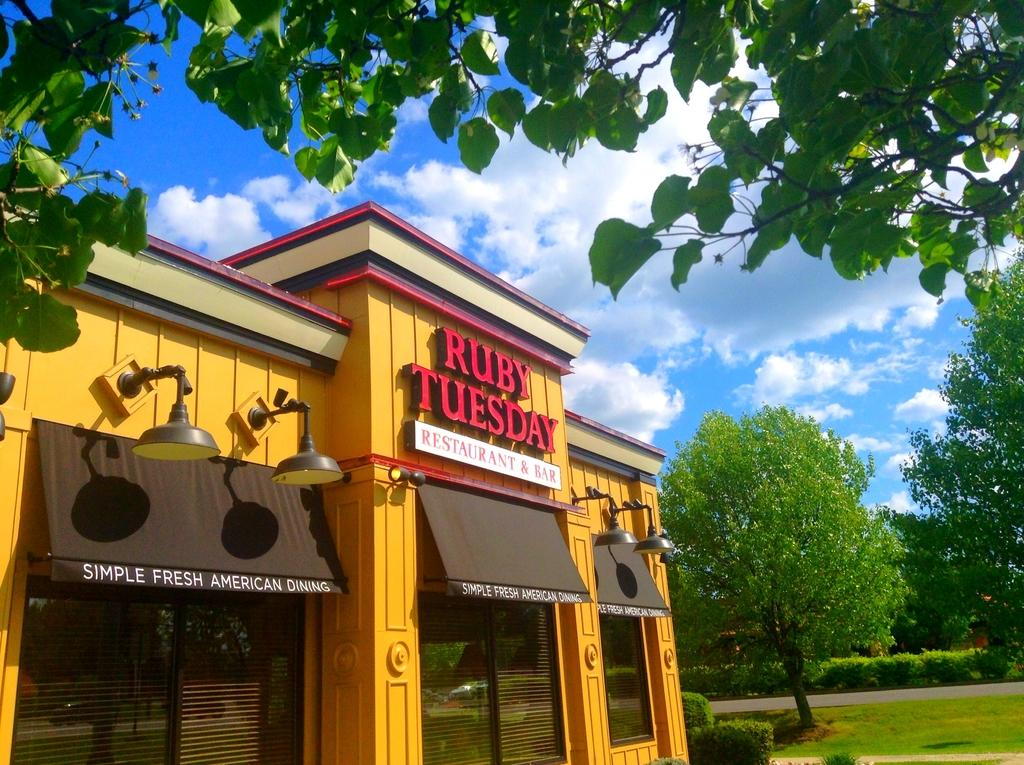What type of establishment is the building in the image? The building is a bar and restaurant. What color is the building? The building is yellow in color. What type of vegetation is visible in the image? There are green trees in the image. What color is the sky in the image? The sky is blue in color. What type of jelly is being served at the bar in the image? There is no jelly present in the image, as it is a bar and restaurant, not a place that serves jelly. 